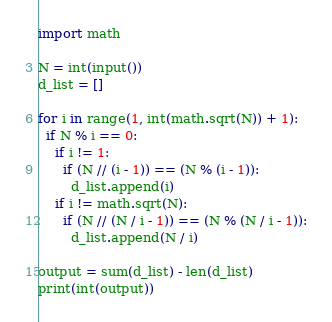Convert code to text. <code><loc_0><loc_0><loc_500><loc_500><_Python_>import math
 
N = int(input())
d_list = []
 
for i in range(1, int(math.sqrt(N)) + 1):
  if N % i == 0:
    if i != 1:
      if (N // (i - 1)) == (N % (i - 1)):
        d_list.append(i)
    if i != math.sqrt(N):
      if (N // (N / i - 1)) == (N % (N / i - 1)):
        d_list.append(N / i)
 
output = sum(d_list) - len(d_list)
print(int(output))</code> 